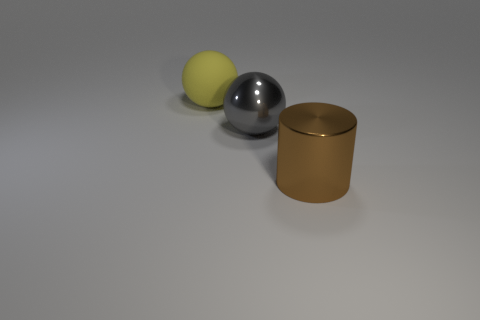Add 1 large blue metal cubes. How many objects exist? 4 Subtract all balls. How many objects are left? 1 Add 1 spheres. How many spheres are left? 3 Add 3 gray metal spheres. How many gray metal spheres exist? 4 Subtract 0 yellow cylinders. How many objects are left? 3 Subtract all small shiny blocks. Subtract all cylinders. How many objects are left? 2 